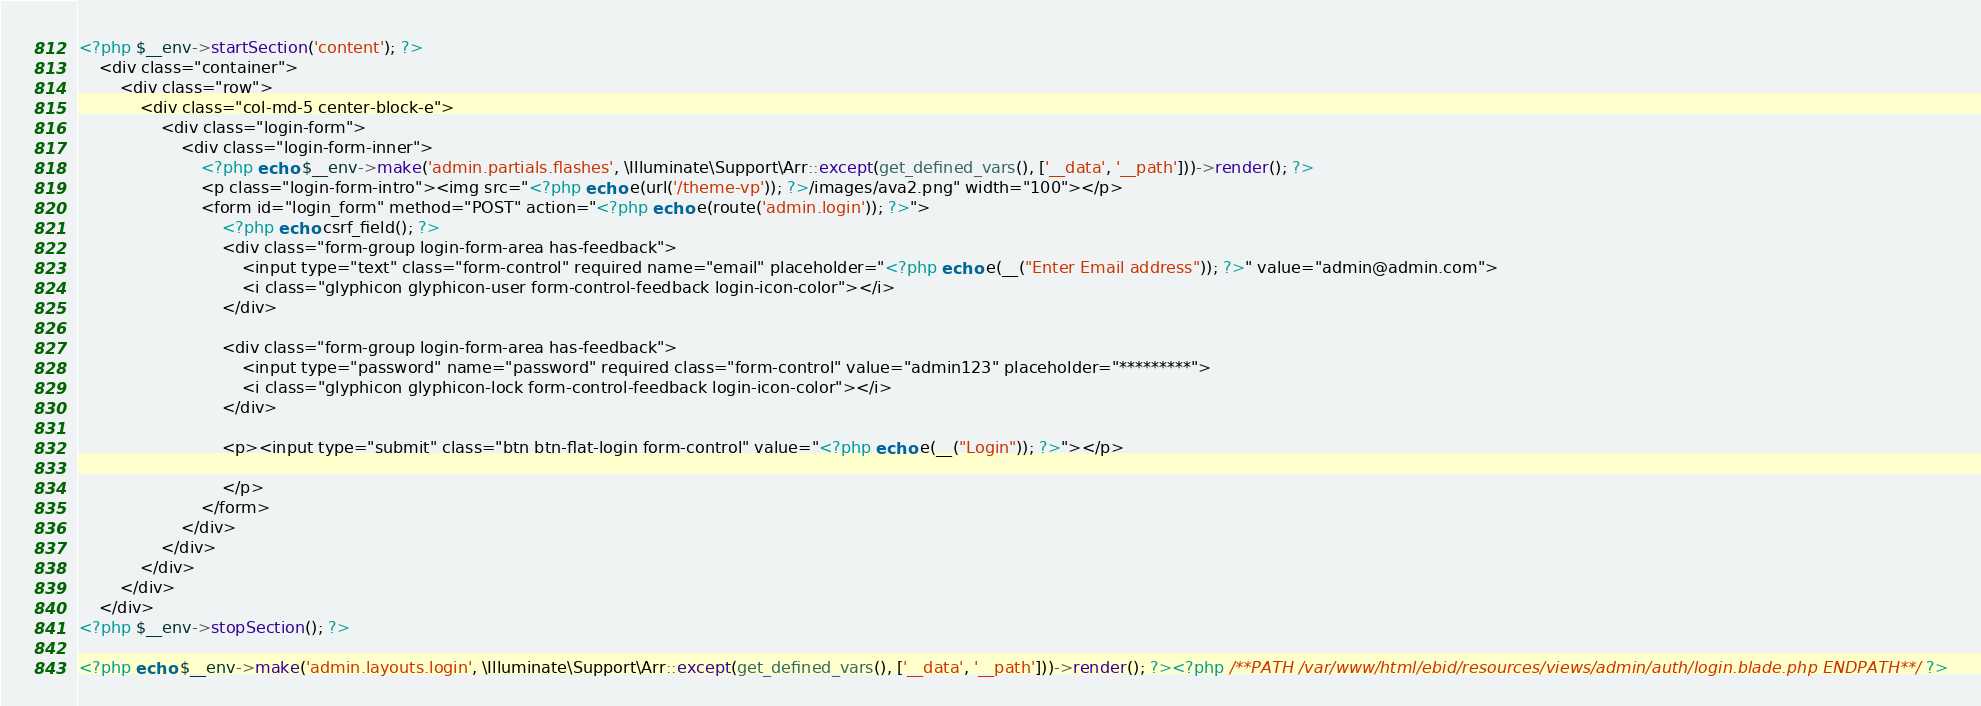Convert code to text. <code><loc_0><loc_0><loc_500><loc_500><_PHP_><?php $__env->startSection('content'); ?>
    <div class="container">
        <div class="row">
            <div class="col-md-5 center-block-e">
                <div class="login-form">
                    <div class="login-form-inner">
                        <?php echo $__env->make('admin.partials.flashes', \Illuminate\Support\Arr::except(get_defined_vars(), ['__data', '__path']))->render(); ?>
                        <p class="login-form-intro"><img src="<?php echo e(url('/theme-vp')); ?>/images/ava2.png" width="100"></p>
                        <form id="login_form" method="POST" action="<?php echo e(route('admin.login')); ?>">
                            <?php echo csrf_field(); ?>
                            <div class="form-group login-form-area has-feedback">
                                <input type="text" class="form-control" required name="email" placeholder="<?php echo e(__("Enter Email address")); ?>" value="admin@admin.com">
                                <i class="glyphicon glyphicon-user form-control-feedback login-icon-color"></i>
                            </div>

                            <div class="form-group login-form-area has-feedback">
                                <input type="password" name="password" required class="form-control" value="admin123" placeholder="*********">
                                <i class="glyphicon glyphicon-lock form-control-feedback login-icon-color"></i>
                            </div>

                            <p><input type="submit" class="btn btn-flat-login form-control" value="<?php echo e(__("Login")); ?>"></p>

                            </p>
                        </form>
                    </div>
                </div>
            </div>
        </div>
    </div>
<?php $__env->stopSection(); ?>

<?php echo $__env->make('admin.layouts.login', \Illuminate\Support\Arr::except(get_defined_vars(), ['__data', '__path']))->render(); ?><?php /**PATH /var/www/html/ebid/resources/views/admin/auth/login.blade.php ENDPATH**/ ?></code> 